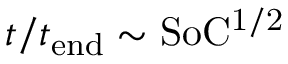Convert formula to latex. <formula><loc_0><loc_0><loc_500><loc_500>t / t _ { e n d } \sim S o C ^ { 1 / 2 }</formula> 